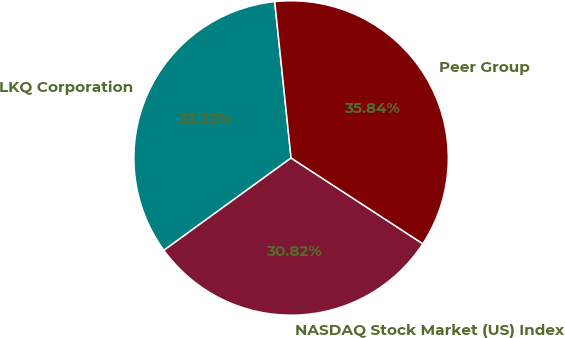Convert chart to OTSL. <chart><loc_0><loc_0><loc_500><loc_500><pie_chart><fcel>LKQ Corporation<fcel>NASDAQ Stock Market (US) Index<fcel>Peer Group<nl><fcel>33.33%<fcel>30.82%<fcel>35.84%<nl></chart> 